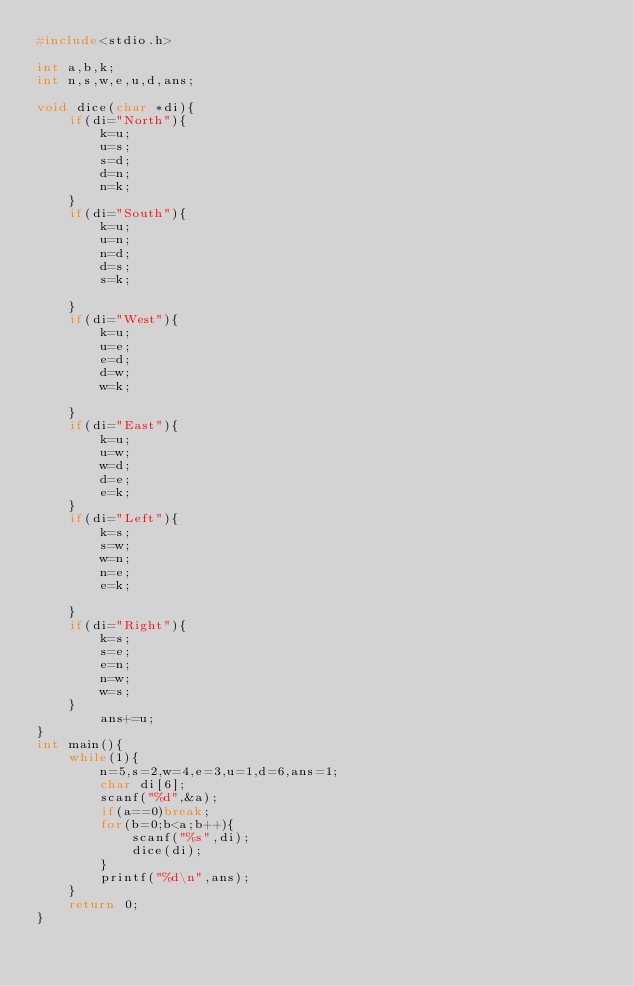<code> <loc_0><loc_0><loc_500><loc_500><_C_>#include<stdio.h>

int a,b,k;
int n,s,w,e,u,d,ans;

void dice(char *di){
	if(di="North"){	
		k=u;
		u=s;
		s=d;
		d=n;
		n=k;
	}
	if(di="South"){
		k=u;
		u=n;
		n=d;
		d=s;
		s=k;
		
	}
	if(di="West"){
		k=u;
		u=e;
		e=d;
		d=w;
		w=k;
		
	}
	if(di="East"){
		k=u;
		u=w;
		w=d;
		d=e;
		e=k;
	}
	if(di="Left"){
		k=s;
		s=w;
		w=n;
		n=e;
		e=k;
		
	}
	if(di="Right"){
		k=s;
		s=e;
		e=n;
		n=w;
		w=s;
	}
        ans+=u;                  
}
int main(){
	while(1){
		n=5,s=2,w=4,e=3,u=1,d=6,ans=1;
		char di[6];
		scanf("%d",&a);
		if(a==0)break;
		for(b=0;b<a;b++){
			scanf("%s",di);
			dice(di);
		}
		printf("%d\n",ans);
	}
	return 0;
}</code> 